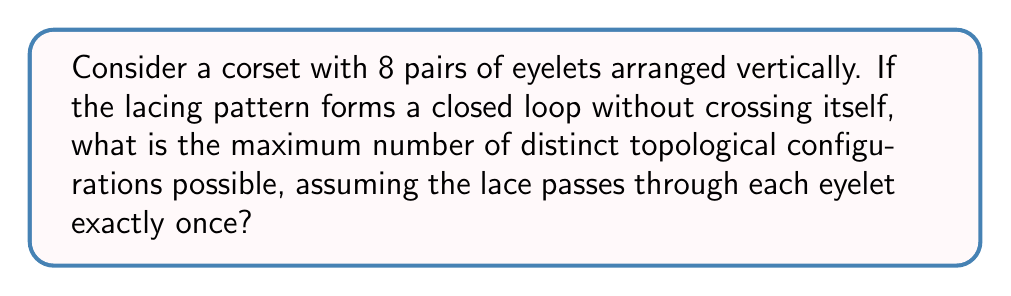Give your solution to this math problem. To solve this problem, we'll follow these steps:

1) First, we need to recognize that this problem is equivalent to counting the number of non-crossing perfect matchings on a circle with 16 points (8 pairs of eyelets).

2) This is a well-known problem in combinatorics, and the answer is given by the Catalan number $C_n$, where $n$ is half the number of points.

3) The formula for the $n$-th Catalan number is:

   $$C_n = \frac{1}{n+1}\binom{2n}{n}$$

4) In our case, $n = 8$ (half of 16 eyelets), so we need to calculate $C_8$:

   $$C_8 = \frac{1}{9}\binom{16}{8}$$

5) Let's calculate $\binom{16}{8}$:

   $$\binom{16}{8} = \frac{16!}{8!(16-8)!} = \frac{16!}{8!8!} = 12870$$

6) Now we can complete our calculation:

   $$C_8 = \frac{1}{9} \cdot 12870 = 1430$$

Therefore, there are 1430 distinct topological configurations possible for the corset lacing.

This result connects to feminist theory and 19th-century British literature by providing a mathematical perspective on the complexity and variety of corset lacing patterns, which were a significant aspect of women's fashion and societal norms in that era.
Answer: 1430 